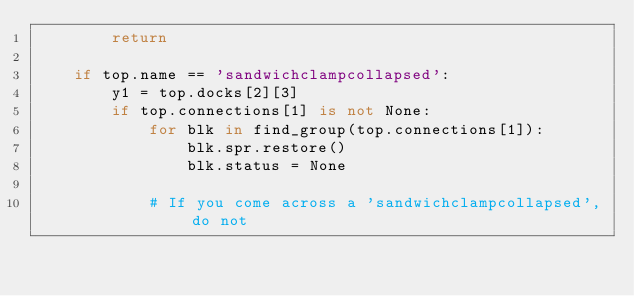<code> <loc_0><loc_0><loc_500><loc_500><_Python_>        return

    if top.name == 'sandwichclampcollapsed':
        y1 = top.docks[2][3]
        if top.connections[1] is not None:
            for blk in find_group(top.connections[1]):
                blk.spr.restore()
                blk.status = None

            # If you come across a 'sandwichclampcollapsed', do not</code> 